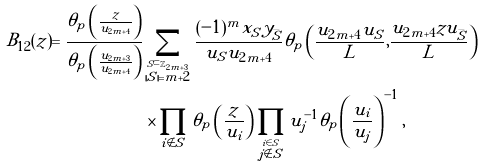<formula> <loc_0><loc_0><loc_500><loc_500>B _ { 1 2 } ( z ) = \frac { \theta _ { p } \left ( \frac { z } { u _ { 2 m + 4 } } \right ) } { \theta _ { p } \left ( \frac { u _ { 2 m + 3 } } { u _ { 2 m + 4 } } \right ) } & \sum _ { \stackrel { S \subset \mathbb { Z } _ { 2 m + 3 } } { | S | = m + 2 } } \frac { ( - 1 ) ^ { m } x _ { S } y _ { \bar { S } } } { u _ { S } u _ { 2 m + 4 } } \theta _ { p } \left ( \frac { u _ { 2 m + 4 } u _ { S } } { L } , \frac { u _ { 2 m + 4 } z u _ { \bar { S } } } { L } \right ) \\ & \times \prod _ { i \notin S } \theta _ { p } \left ( \frac { z } { u _ { i } } \right ) \prod _ { \stackrel { i \in S } { j \notin S } } u _ { j } ^ { - 1 } \theta _ { p } \left ( \frac { u _ { i } } { u _ { j } } \right ) ^ { - 1 } ,</formula> 